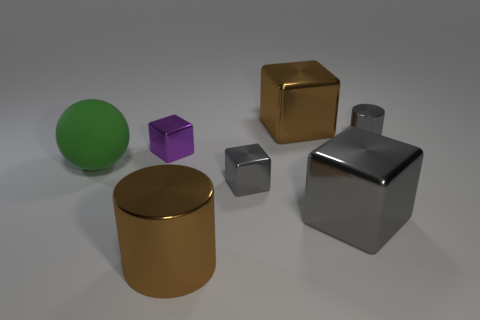How many red rubber cylinders have the same size as the matte sphere?
Ensure brevity in your answer.  0. There is a large metal thing that is the same color as the small metallic cylinder; what shape is it?
Keep it short and to the point. Cube. Are any blocks visible?
Keep it short and to the point. Yes. There is a brown thing that is behind the big metal cylinder; is its shape the same as the large brown object in front of the gray cylinder?
Your answer should be very brief. No. How many tiny things are balls or brown metal cubes?
Provide a succinct answer. 0. What is the shape of the big brown object that is made of the same material as the brown block?
Offer a terse response. Cylinder. Is the shape of the small purple thing the same as the large gray object?
Make the answer very short. Yes. What color is the large cylinder?
Your answer should be compact. Brown. How many objects are either large purple shiny cubes or big shiny cubes?
Your answer should be compact. 2. Is there any other thing that has the same material as the sphere?
Give a very brief answer. No. 